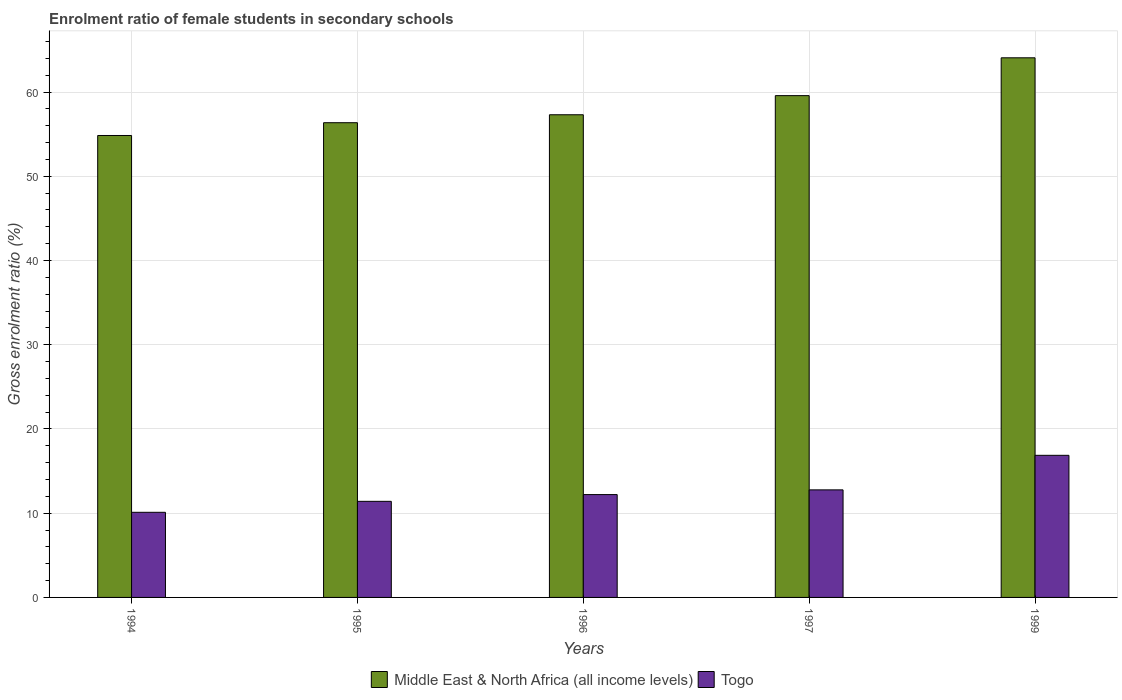How many different coloured bars are there?
Offer a terse response. 2. How many groups of bars are there?
Your response must be concise. 5. How many bars are there on the 2nd tick from the right?
Provide a short and direct response. 2. What is the label of the 2nd group of bars from the left?
Make the answer very short. 1995. What is the enrolment ratio of female students in secondary schools in Togo in 1995?
Your response must be concise. 11.41. Across all years, what is the maximum enrolment ratio of female students in secondary schools in Togo?
Your answer should be very brief. 16.87. Across all years, what is the minimum enrolment ratio of female students in secondary schools in Middle East & North Africa (all income levels)?
Make the answer very short. 54.85. What is the total enrolment ratio of female students in secondary schools in Middle East & North Africa (all income levels) in the graph?
Offer a terse response. 292.16. What is the difference between the enrolment ratio of female students in secondary schools in Togo in 1994 and that in 1999?
Provide a succinct answer. -6.76. What is the difference between the enrolment ratio of female students in secondary schools in Middle East & North Africa (all income levels) in 1999 and the enrolment ratio of female students in secondary schools in Togo in 1994?
Give a very brief answer. 53.96. What is the average enrolment ratio of female students in secondary schools in Middle East & North Africa (all income levels) per year?
Give a very brief answer. 58.43. In the year 1999, what is the difference between the enrolment ratio of female students in secondary schools in Togo and enrolment ratio of female students in secondary schools in Middle East & North Africa (all income levels)?
Ensure brevity in your answer.  -47.2. In how many years, is the enrolment ratio of female students in secondary schools in Middle East & North Africa (all income levels) greater than 60 %?
Your response must be concise. 1. What is the ratio of the enrolment ratio of female students in secondary schools in Togo in 1994 to that in 1997?
Your answer should be compact. 0.79. Is the enrolment ratio of female students in secondary schools in Middle East & North Africa (all income levels) in 1994 less than that in 1995?
Give a very brief answer. Yes. Is the difference between the enrolment ratio of female students in secondary schools in Togo in 1995 and 1996 greater than the difference between the enrolment ratio of female students in secondary schools in Middle East & North Africa (all income levels) in 1995 and 1996?
Provide a succinct answer. Yes. What is the difference between the highest and the second highest enrolment ratio of female students in secondary schools in Middle East & North Africa (all income levels)?
Offer a very short reply. 4.49. What is the difference between the highest and the lowest enrolment ratio of female students in secondary schools in Togo?
Provide a succinct answer. 6.76. In how many years, is the enrolment ratio of female students in secondary schools in Middle East & North Africa (all income levels) greater than the average enrolment ratio of female students in secondary schools in Middle East & North Africa (all income levels) taken over all years?
Offer a terse response. 2. Is the sum of the enrolment ratio of female students in secondary schools in Togo in 1996 and 1999 greater than the maximum enrolment ratio of female students in secondary schools in Middle East & North Africa (all income levels) across all years?
Ensure brevity in your answer.  No. What does the 1st bar from the left in 1996 represents?
Provide a succinct answer. Middle East & North Africa (all income levels). What does the 2nd bar from the right in 1997 represents?
Give a very brief answer. Middle East & North Africa (all income levels). Are all the bars in the graph horizontal?
Provide a short and direct response. No. How many years are there in the graph?
Your response must be concise. 5. Are the values on the major ticks of Y-axis written in scientific E-notation?
Your answer should be compact. No. Does the graph contain any zero values?
Make the answer very short. No. Does the graph contain grids?
Make the answer very short. Yes. How are the legend labels stacked?
Keep it short and to the point. Horizontal. What is the title of the graph?
Your answer should be very brief. Enrolment ratio of female students in secondary schools. Does "Serbia" appear as one of the legend labels in the graph?
Your answer should be very brief. No. What is the Gross enrolment ratio (%) of Middle East & North Africa (all income levels) in 1994?
Give a very brief answer. 54.85. What is the Gross enrolment ratio (%) of Togo in 1994?
Your response must be concise. 10.11. What is the Gross enrolment ratio (%) of Middle East & North Africa (all income levels) in 1995?
Your answer should be very brief. 56.36. What is the Gross enrolment ratio (%) in Togo in 1995?
Provide a succinct answer. 11.41. What is the Gross enrolment ratio (%) of Middle East & North Africa (all income levels) in 1996?
Keep it short and to the point. 57.31. What is the Gross enrolment ratio (%) in Togo in 1996?
Keep it short and to the point. 12.21. What is the Gross enrolment ratio (%) in Middle East & North Africa (all income levels) in 1997?
Ensure brevity in your answer.  59.58. What is the Gross enrolment ratio (%) of Togo in 1997?
Provide a succinct answer. 12.77. What is the Gross enrolment ratio (%) of Middle East & North Africa (all income levels) in 1999?
Give a very brief answer. 64.07. What is the Gross enrolment ratio (%) in Togo in 1999?
Ensure brevity in your answer.  16.87. Across all years, what is the maximum Gross enrolment ratio (%) in Middle East & North Africa (all income levels)?
Offer a very short reply. 64.07. Across all years, what is the maximum Gross enrolment ratio (%) in Togo?
Make the answer very short. 16.87. Across all years, what is the minimum Gross enrolment ratio (%) in Middle East & North Africa (all income levels)?
Your answer should be compact. 54.85. Across all years, what is the minimum Gross enrolment ratio (%) in Togo?
Ensure brevity in your answer.  10.11. What is the total Gross enrolment ratio (%) of Middle East & North Africa (all income levels) in the graph?
Your response must be concise. 292.16. What is the total Gross enrolment ratio (%) of Togo in the graph?
Provide a short and direct response. 63.37. What is the difference between the Gross enrolment ratio (%) in Middle East & North Africa (all income levels) in 1994 and that in 1995?
Offer a very short reply. -1.52. What is the difference between the Gross enrolment ratio (%) in Togo in 1994 and that in 1995?
Offer a very short reply. -1.3. What is the difference between the Gross enrolment ratio (%) of Middle East & North Africa (all income levels) in 1994 and that in 1996?
Offer a very short reply. -2.46. What is the difference between the Gross enrolment ratio (%) in Togo in 1994 and that in 1996?
Ensure brevity in your answer.  -2.1. What is the difference between the Gross enrolment ratio (%) in Middle East & North Africa (all income levels) in 1994 and that in 1997?
Keep it short and to the point. -4.73. What is the difference between the Gross enrolment ratio (%) of Togo in 1994 and that in 1997?
Offer a terse response. -2.66. What is the difference between the Gross enrolment ratio (%) in Middle East & North Africa (all income levels) in 1994 and that in 1999?
Make the answer very short. -9.22. What is the difference between the Gross enrolment ratio (%) in Togo in 1994 and that in 1999?
Keep it short and to the point. -6.76. What is the difference between the Gross enrolment ratio (%) of Middle East & North Africa (all income levels) in 1995 and that in 1996?
Your response must be concise. -0.94. What is the difference between the Gross enrolment ratio (%) of Togo in 1995 and that in 1996?
Your answer should be compact. -0.8. What is the difference between the Gross enrolment ratio (%) in Middle East & North Africa (all income levels) in 1995 and that in 1997?
Your answer should be very brief. -3.21. What is the difference between the Gross enrolment ratio (%) in Togo in 1995 and that in 1997?
Ensure brevity in your answer.  -1.36. What is the difference between the Gross enrolment ratio (%) in Middle East & North Africa (all income levels) in 1995 and that in 1999?
Make the answer very short. -7.71. What is the difference between the Gross enrolment ratio (%) in Togo in 1995 and that in 1999?
Keep it short and to the point. -5.46. What is the difference between the Gross enrolment ratio (%) of Middle East & North Africa (all income levels) in 1996 and that in 1997?
Provide a short and direct response. -2.27. What is the difference between the Gross enrolment ratio (%) in Togo in 1996 and that in 1997?
Provide a succinct answer. -0.56. What is the difference between the Gross enrolment ratio (%) in Middle East & North Africa (all income levels) in 1996 and that in 1999?
Offer a terse response. -6.76. What is the difference between the Gross enrolment ratio (%) in Togo in 1996 and that in 1999?
Offer a terse response. -4.66. What is the difference between the Gross enrolment ratio (%) in Middle East & North Africa (all income levels) in 1997 and that in 1999?
Ensure brevity in your answer.  -4.49. What is the difference between the Gross enrolment ratio (%) of Togo in 1997 and that in 1999?
Your answer should be compact. -4.1. What is the difference between the Gross enrolment ratio (%) in Middle East & North Africa (all income levels) in 1994 and the Gross enrolment ratio (%) in Togo in 1995?
Provide a succinct answer. 43.44. What is the difference between the Gross enrolment ratio (%) in Middle East & North Africa (all income levels) in 1994 and the Gross enrolment ratio (%) in Togo in 1996?
Offer a very short reply. 42.63. What is the difference between the Gross enrolment ratio (%) of Middle East & North Africa (all income levels) in 1994 and the Gross enrolment ratio (%) of Togo in 1997?
Offer a terse response. 42.08. What is the difference between the Gross enrolment ratio (%) of Middle East & North Africa (all income levels) in 1994 and the Gross enrolment ratio (%) of Togo in 1999?
Give a very brief answer. 37.97. What is the difference between the Gross enrolment ratio (%) of Middle East & North Africa (all income levels) in 1995 and the Gross enrolment ratio (%) of Togo in 1996?
Offer a very short reply. 44.15. What is the difference between the Gross enrolment ratio (%) in Middle East & North Africa (all income levels) in 1995 and the Gross enrolment ratio (%) in Togo in 1997?
Provide a short and direct response. 43.59. What is the difference between the Gross enrolment ratio (%) of Middle East & North Africa (all income levels) in 1995 and the Gross enrolment ratio (%) of Togo in 1999?
Your answer should be compact. 39.49. What is the difference between the Gross enrolment ratio (%) of Middle East & North Africa (all income levels) in 1996 and the Gross enrolment ratio (%) of Togo in 1997?
Provide a succinct answer. 44.54. What is the difference between the Gross enrolment ratio (%) of Middle East & North Africa (all income levels) in 1996 and the Gross enrolment ratio (%) of Togo in 1999?
Ensure brevity in your answer.  40.43. What is the difference between the Gross enrolment ratio (%) in Middle East & North Africa (all income levels) in 1997 and the Gross enrolment ratio (%) in Togo in 1999?
Your answer should be compact. 42.71. What is the average Gross enrolment ratio (%) in Middle East & North Africa (all income levels) per year?
Make the answer very short. 58.43. What is the average Gross enrolment ratio (%) in Togo per year?
Offer a terse response. 12.67. In the year 1994, what is the difference between the Gross enrolment ratio (%) in Middle East & North Africa (all income levels) and Gross enrolment ratio (%) in Togo?
Provide a succinct answer. 44.74. In the year 1995, what is the difference between the Gross enrolment ratio (%) of Middle East & North Africa (all income levels) and Gross enrolment ratio (%) of Togo?
Make the answer very short. 44.95. In the year 1996, what is the difference between the Gross enrolment ratio (%) in Middle East & North Africa (all income levels) and Gross enrolment ratio (%) in Togo?
Your answer should be very brief. 45.1. In the year 1997, what is the difference between the Gross enrolment ratio (%) in Middle East & North Africa (all income levels) and Gross enrolment ratio (%) in Togo?
Your answer should be very brief. 46.81. In the year 1999, what is the difference between the Gross enrolment ratio (%) in Middle East & North Africa (all income levels) and Gross enrolment ratio (%) in Togo?
Your answer should be very brief. 47.2. What is the ratio of the Gross enrolment ratio (%) in Middle East & North Africa (all income levels) in 1994 to that in 1995?
Your answer should be compact. 0.97. What is the ratio of the Gross enrolment ratio (%) of Togo in 1994 to that in 1995?
Give a very brief answer. 0.89. What is the ratio of the Gross enrolment ratio (%) in Middle East & North Africa (all income levels) in 1994 to that in 1996?
Keep it short and to the point. 0.96. What is the ratio of the Gross enrolment ratio (%) of Togo in 1994 to that in 1996?
Provide a short and direct response. 0.83. What is the ratio of the Gross enrolment ratio (%) of Middle East & North Africa (all income levels) in 1994 to that in 1997?
Ensure brevity in your answer.  0.92. What is the ratio of the Gross enrolment ratio (%) of Togo in 1994 to that in 1997?
Make the answer very short. 0.79. What is the ratio of the Gross enrolment ratio (%) of Middle East & North Africa (all income levels) in 1994 to that in 1999?
Keep it short and to the point. 0.86. What is the ratio of the Gross enrolment ratio (%) in Togo in 1994 to that in 1999?
Provide a succinct answer. 0.6. What is the ratio of the Gross enrolment ratio (%) in Middle East & North Africa (all income levels) in 1995 to that in 1996?
Offer a terse response. 0.98. What is the ratio of the Gross enrolment ratio (%) of Togo in 1995 to that in 1996?
Your response must be concise. 0.93. What is the ratio of the Gross enrolment ratio (%) of Middle East & North Africa (all income levels) in 1995 to that in 1997?
Your response must be concise. 0.95. What is the ratio of the Gross enrolment ratio (%) in Togo in 1995 to that in 1997?
Make the answer very short. 0.89. What is the ratio of the Gross enrolment ratio (%) in Middle East & North Africa (all income levels) in 1995 to that in 1999?
Make the answer very short. 0.88. What is the ratio of the Gross enrolment ratio (%) of Togo in 1995 to that in 1999?
Make the answer very short. 0.68. What is the ratio of the Gross enrolment ratio (%) in Middle East & North Africa (all income levels) in 1996 to that in 1997?
Give a very brief answer. 0.96. What is the ratio of the Gross enrolment ratio (%) in Togo in 1996 to that in 1997?
Your response must be concise. 0.96. What is the ratio of the Gross enrolment ratio (%) in Middle East & North Africa (all income levels) in 1996 to that in 1999?
Give a very brief answer. 0.89. What is the ratio of the Gross enrolment ratio (%) of Togo in 1996 to that in 1999?
Provide a short and direct response. 0.72. What is the ratio of the Gross enrolment ratio (%) of Middle East & North Africa (all income levels) in 1997 to that in 1999?
Ensure brevity in your answer.  0.93. What is the ratio of the Gross enrolment ratio (%) in Togo in 1997 to that in 1999?
Offer a terse response. 0.76. What is the difference between the highest and the second highest Gross enrolment ratio (%) of Middle East & North Africa (all income levels)?
Your response must be concise. 4.49. What is the difference between the highest and the second highest Gross enrolment ratio (%) in Togo?
Ensure brevity in your answer.  4.1. What is the difference between the highest and the lowest Gross enrolment ratio (%) in Middle East & North Africa (all income levels)?
Keep it short and to the point. 9.22. What is the difference between the highest and the lowest Gross enrolment ratio (%) of Togo?
Your response must be concise. 6.76. 